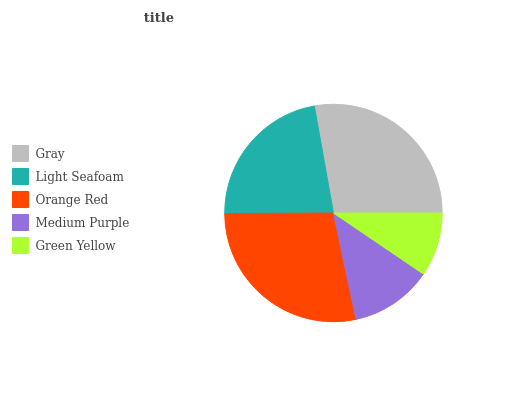Is Green Yellow the minimum?
Answer yes or no. Yes. Is Orange Red the maximum?
Answer yes or no. Yes. Is Light Seafoam the minimum?
Answer yes or no. No. Is Light Seafoam the maximum?
Answer yes or no. No. Is Gray greater than Light Seafoam?
Answer yes or no. Yes. Is Light Seafoam less than Gray?
Answer yes or no. Yes. Is Light Seafoam greater than Gray?
Answer yes or no. No. Is Gray less than Light Seafoam?
Answer yes or no. No. Is Light Seafoam the high median?
Answer yes or no. Yes. Is Light Seafoam the low median?
Answer yes or no. Yes. Is Orange Red the high median?
Answer yes or no. No. Is Orange Red the low median?
Answer yes or no. No. 